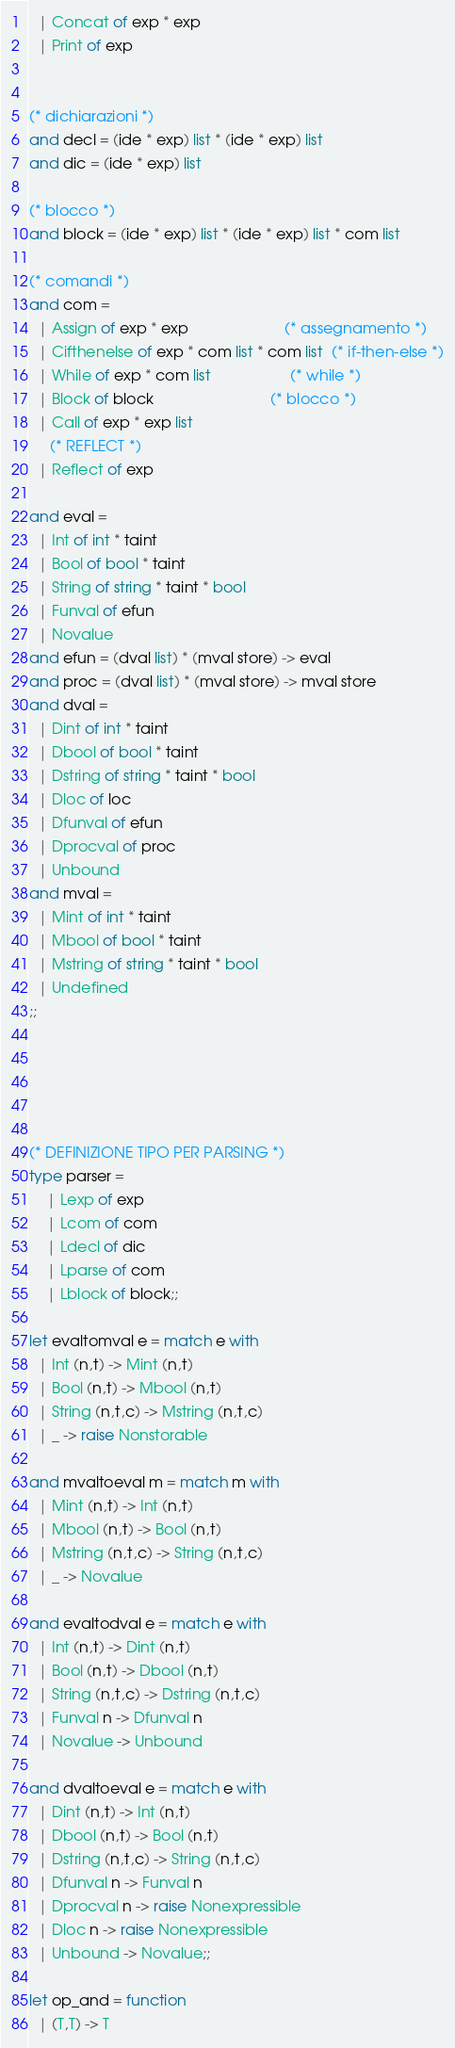<code> <loc_0><loc_0><loc_500><loc_500><_OCaml_>  | Concat of exp * exp
  | Print of exp
 

(* dichiarazioni *)
and decl = (ide * exp) list * (ide * exp) list
and dic = (ide * exp) list 

(* blocco *)
and block = (ide * exp) list * (ide * exp) list * com list
	
(* comandi *)
and com = 
  | Assign of exp * exp                       (* assegnamento *)
  | Cifthenelse of exp * com list * com list  (* if-then-else *)
  | While of exp * com list                   (* while *)
  | Block of block                            (* blocco *)
  | Call of exp * exp list
	 (* REFLECT *)
  | Reflect of exp
    
and eval =
  | Int of int * taint
  | Bool of bool * taint
  | String of string * taint * bool
  | Funval of efun
  | Novalue
and efun = (dval list) * (mval store) -> eval
and proc = (dval list) * (mval store) -> mval store
and dval =
  | Dint of int * taint
  | Dbool of bool * taint
  | Dstring of string * taint * bool
  | Dloc of loc
  | Dfunval of efun
  | Dprocval of proc
  | Unbound
and mval =
  | Mint of int * taint
  | Mbool of bool * taint
  | Mstring of string * taint * bool
  | Undefined
;;





(* DEFINIZIONE TIPO PER PARSING *)
type parser = 
	| Lexp of exp 
	| Lcom of com
	| Ldecl of dic
	| Lparse of com
	| Lblock of block;;

let evaltomval e = match e with
  | Int (n,t) -> Mint (n,t)
  | Bool (n,t) -> Mbool (n,t)
  | String (n,t,c) -> Mstring (n,t,c)
  | _ -> raise Nonstorable

and mvaltoeval m = match m with
  | Mint (n,t) -> Int (n,t)
  | Mbool (n,t) -> Bool (n,t)
  | Mstring (n,t,c) -> String (n,t,c)
  | _ -> Novalue

and evaltodval e = match e with
  | Int (n,t) -> Dint (n,t)
  | Bool (n,t) -> Dbool (n,t)
  | String (n,t,c) -> Dstring (n,t,c)
  | Funval n -> Dfunval n
  | Novalue -> Unbound

and dvaltoeval e = match e with
  | Dint (n,t) -> Int (n,t)
  | Dbool (n,t) -> Bool (n,t)
  | Dstring (n,t,c) -> String (n,t,c)
  | Dfunval n -> Funval n
  | Dprocval n -> raise Nonexpressible
  | Dloc n -> raise Nonexpressible
  | Unbound -> Novalue;;

let op_and = function
  | (T,T) -> T</code> 